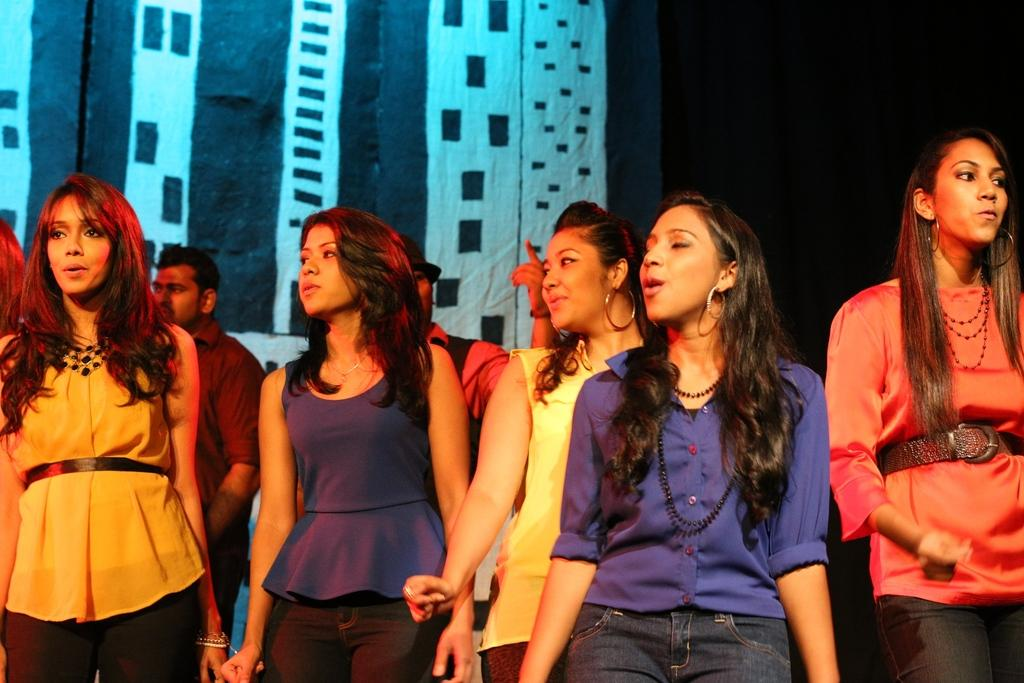What can be seen in the foreground of the picture? There are women standing in the foreground of the picture. What is visible in the background of the picture? There are two men in the background of the picture. What type of covering is present at the top of the image? There are curtains at the top of the image. How many cows are visible in the image? There are no cows present in the image. What type of ball is being used by the women in the image? There is no ball visible in the image; the women are simply standing. 